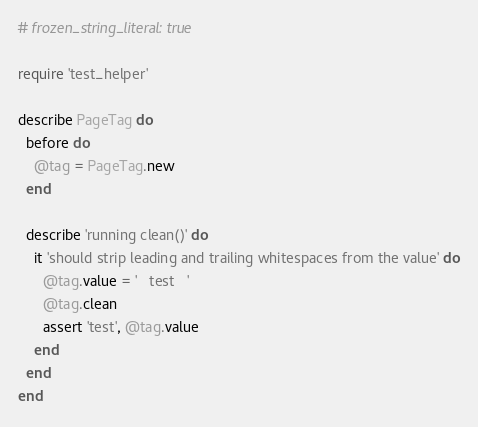<code> <loc_0><loc_0><loc_500><loc_500><_Ruby_># frozen_string_literal: true

require 'test_helper'

describe PageTag do
  before do
    @tag = PageTag.new
  end

  describe 'running clean()' do
    it 'should strip leading and trailing whitespaces from the value' do
      @tag.value = '   test   '
      @tag.clean
      assert 'test', @tag.value
    end
  end
end
</code> 